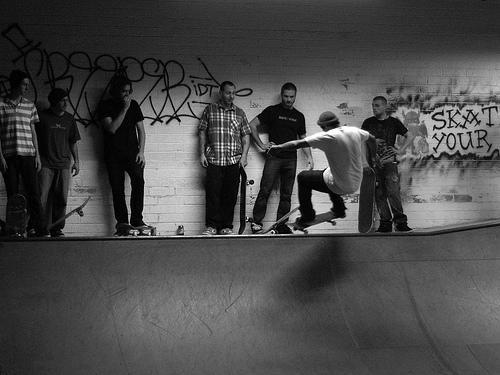How many people are watching the skateboarder?
Give a very brief answer. 6. How many people are there?
Give a very brief answer. 7. 